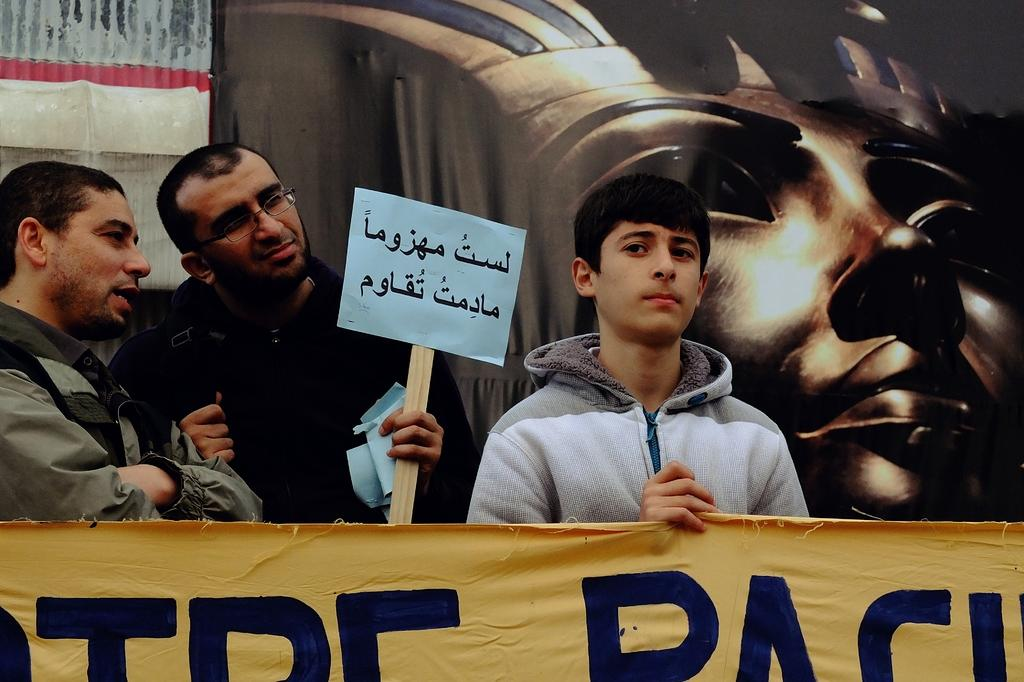How many people are in the image? There are three people in the image. What are the people doing in the image? The people are standing and holding a banner. What can be seen in the background of the image? There is a wall in the background of the image. How many babies are crawling on the wall in the image? There are no babies present in the image, and the wall does not show any crawling babies. 